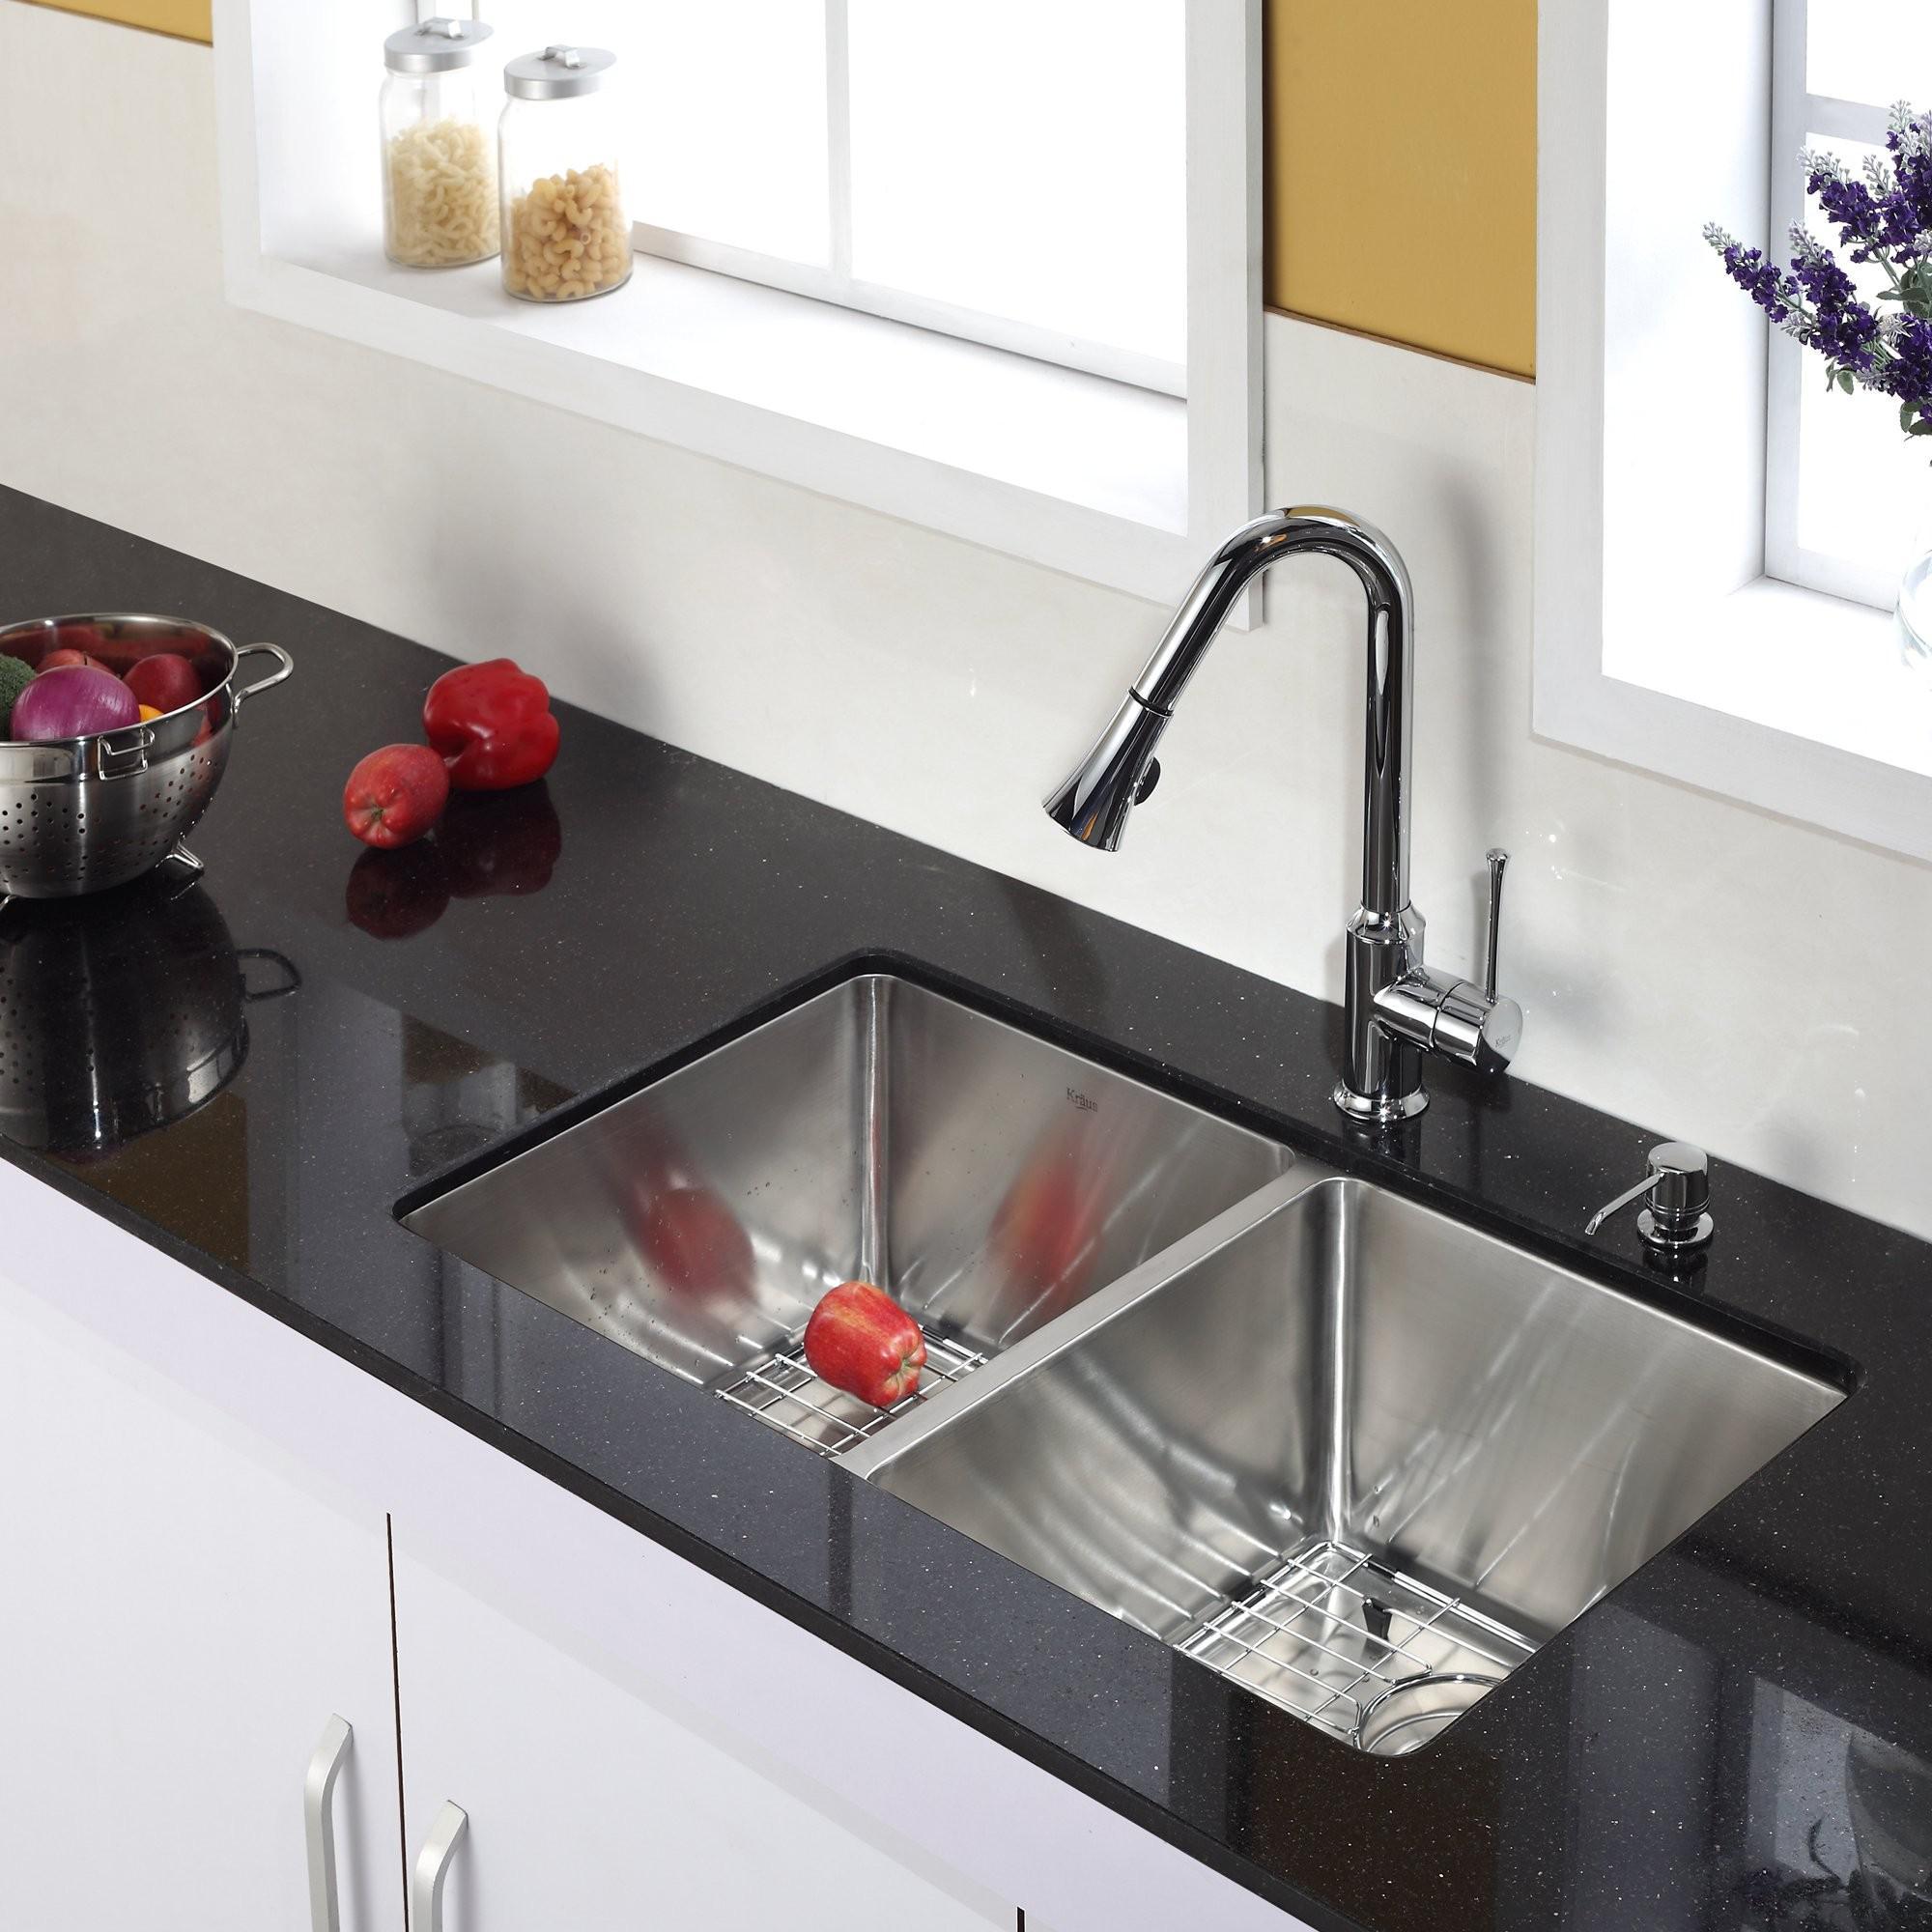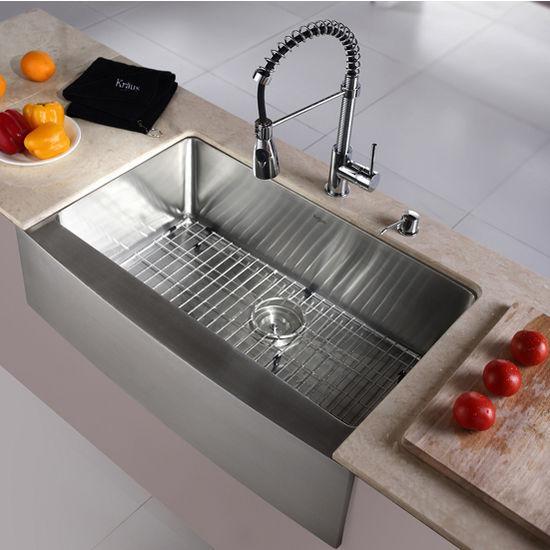The first image is the image on the left, the second image is the image on the right. For the images shown, is this caption "The right image shows a single-basin rectangular sink with a wire rack inside it." true? Answer yes or no. Yes. 